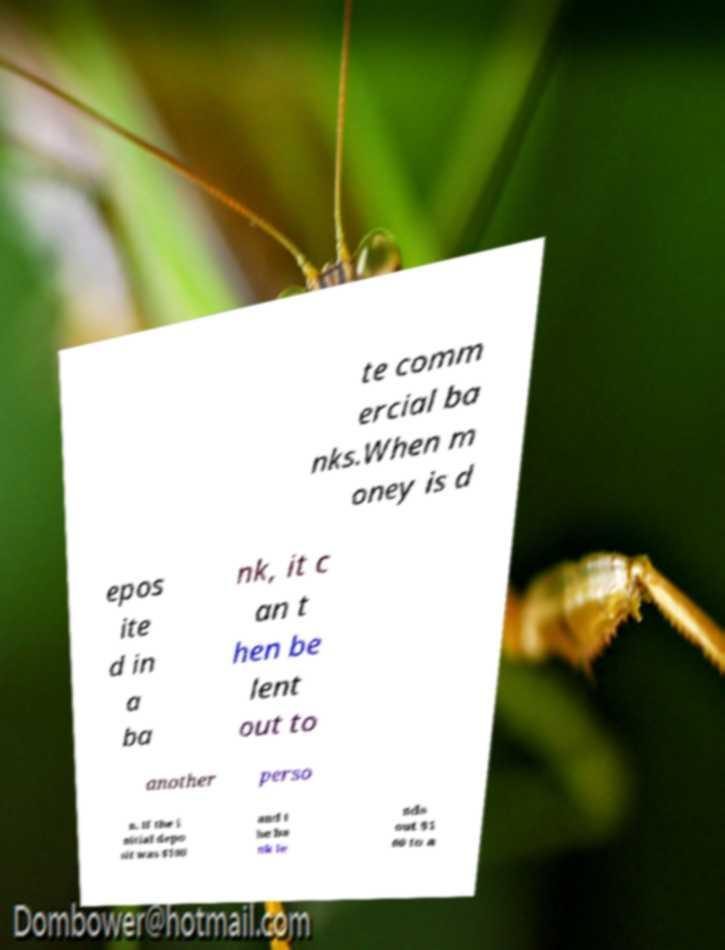There's text embedded in this image that I need extracted. Can you transcribe it verbatim? te comm ercial ba nks.When m oney is d epos ite d in a ba nk, it c an t hen be lent out to another perso n. If the i nitial depo sit was $100 and t he ba nk le nds out $1 00 to a 